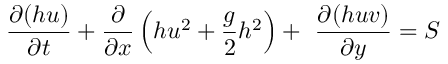<formula> <loc_0><loc_0><loc_500><loc_500>\frac { \partial ( h u ) } { \partial t } + \frac { \partial } { \partial x } \left ( h u ^ { 2 } + \frac { g } { 2 } h ^ { 2 } \right ) + \ \frac { \partial ( h u v ) } { \partial y } = S</formula> 